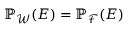<formula> <loc_0><loc_0><loc_500><loc_500>\mathbb { P } _ { \mathcal { W } } ( E ) = \mathbb { P } _ { \mathcal { F } } ( E )</formula> 